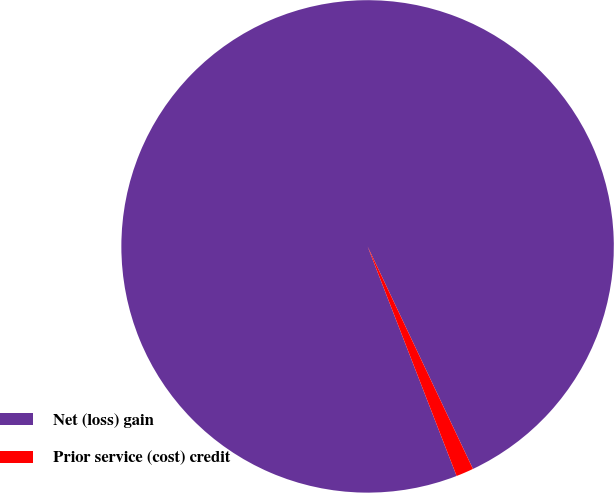Convert chart. <chart><loc_0><loc_0><loc_500><loc_500><pie_chart><fcel>Net (loss) gain<fcel>Prior service (cost) credit<nl><fcel>98.85%<fcel>1.15%<nl></chart> 